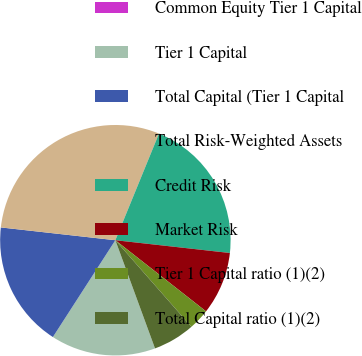<chart> <loc_0><loc_0><loc_500><loc_500><pie_chart><fcel>Common Equity Tier 1 Capital<fcel>Tier 1 Capital<fcel>Total Capital (Tier 1 Capital<fcel>Total Risk-Weighted Assets<fcel>Credit Risk<fcel>Market Risk<fcel>Tier 1 Capital ratio (1)(2)<fcel>Total Capital ratio (1)(2)<nl><fcel>0.0%<fcel>14.71%<fcel>17.65%<fcel>29.41%<fcel>20.59%<fcel>8.82%<fcel>2.94%<fcel>5.88%<nl></chart> 